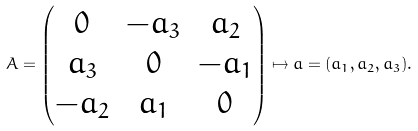Convert formula to latex. <formula><loc_0><loc_0><loc_500><loc_500>A = \begin{pmatrix} 0 & - a _ { 3 } & a _ { 2 } \\ a _ { 3 } & 0 & - a _ { 1 } \\ - a _ { 2 } & a _ { 1 } & 0 \end{pmatrix} \mapsto a = ( a _ { 1 } , a _ { 2 } , a _ { 3 } ) .</formula> 